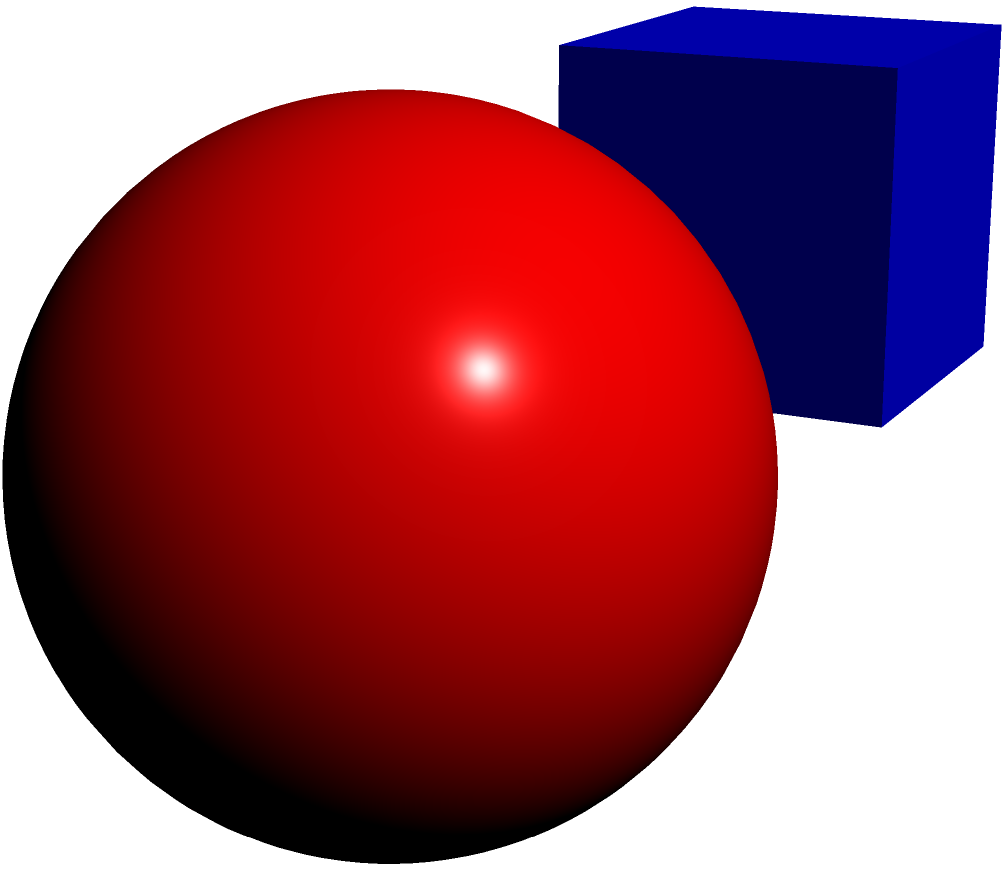Match the 3D shapes (A, B, C) with their corresponding 2D representations (1, 2, 3). Which combination is correct? Let's analyze each 3D shape and its corresponding 2D representation:

1. Shape A is a cube. Its 2D representation would be a square, which is shown in option 2.

2. Shape B is a sphere. Its 2D representation would be a circle, which is shown in option 1.

3. Shape C is a cylinder. Its 2D representation would be a rectangle (representing the side view of the cylinder), which is shown in option 3.

Therefore, the correct matching is:
- A (cube) matches with 2 (square)
- B (sphere) matches with 1 (circle)
- C (cylinder) matches with 3 (rectangle)
Answer: A-2, B-1, C-3 